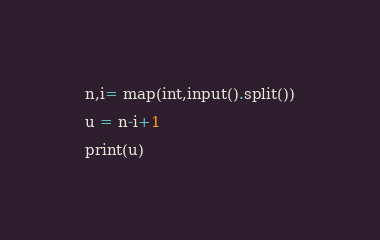Convert code to text. <code><loc_0><loc_0><loc_500><loc_500><_Python_>n,i= map(int,input().split())

u = n-i+1

print(u)
</code> 